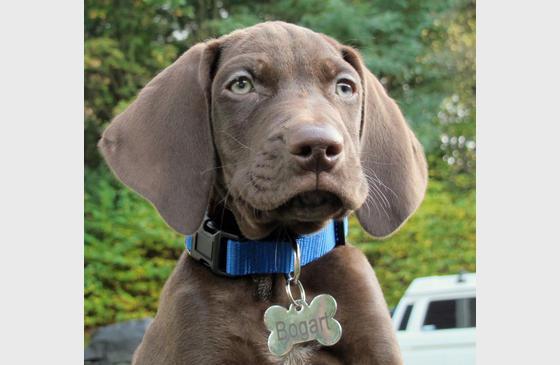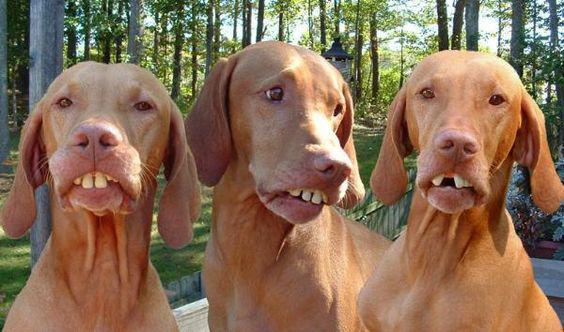The first image is the image on the left, the second image is the image on the right. For the images displayed, is the sentence "There are exactly two dogs in both images." factually correct? Answer yes or no. No. The first image is the image on the left, the second image is the image on the right. Assess this claim about the two images: "The left image shows a brown dog and a gray dog.". Correct or not? Answer yes or no. No. 